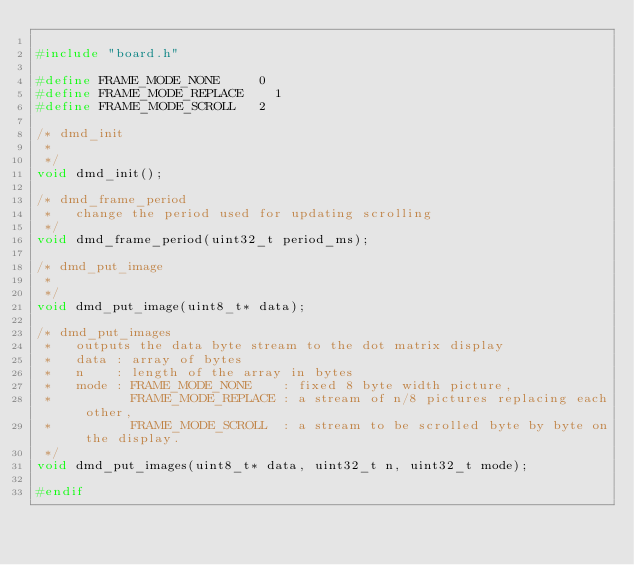<code> <loc_0><loc_0><loc_500><loc_500><_C_>
#include "board.h"

#define FRAME_MODE_NONE			0
#define FRAME_MODE_REPLACE		1
#define FRAME_MODE_SCROLL		2

/* dmd_init
 *
 */
void dmd_init();

/* dmd_frame_period
 *   change the period used for updating scrolling
 */
void dmd_frame_period(uint32_t period_ms);

/* dmd_put_image
 *
 */
void dmd_put_image(uint8_t* data);

/* dmd_put_images
 *   outputs the data byte stream to the dot matrix display
 *   data : array of bytes
 *   n    : length of the array in bytes
 *   mode : FRAME_MODE_NONE    : fixed 8 byte width picture,
 *          FRAME_MODE_REPLACE : a stream of n/8 pictures replacing each other,
 *          FRAME_MODE_SCROLL  : a stream to be scrolled byte by byte on the display.
 */
void dmd_put_images(uint8_t* data, uint32_t n, uint32_t mode);

#endif
</code> 